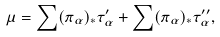<formula> <loc_0><loc_0><loc_500><loc_500>\mu = \sum ( \pi _ { \alpha } ) _ { * } \tau _ { \alpha } ^ { \prime } + \sum ( \pi _ { \alpha } ) _ { * } \tau _ { \alpha } ^ { \prime \prime } ,</formula> 